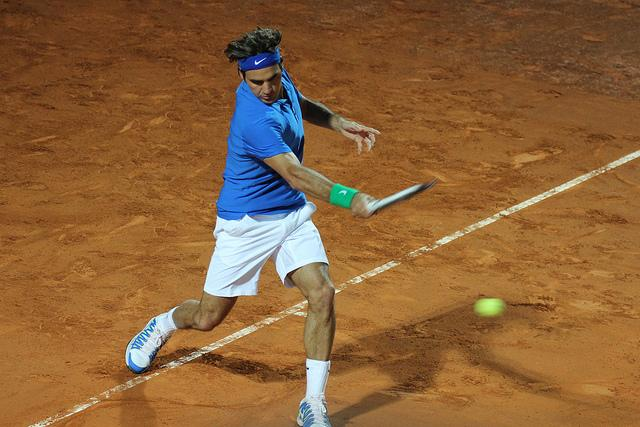What is the man wearing?

Choices:
A) backpack
B) gas mask
C) knee brace
D) bandana bandana 